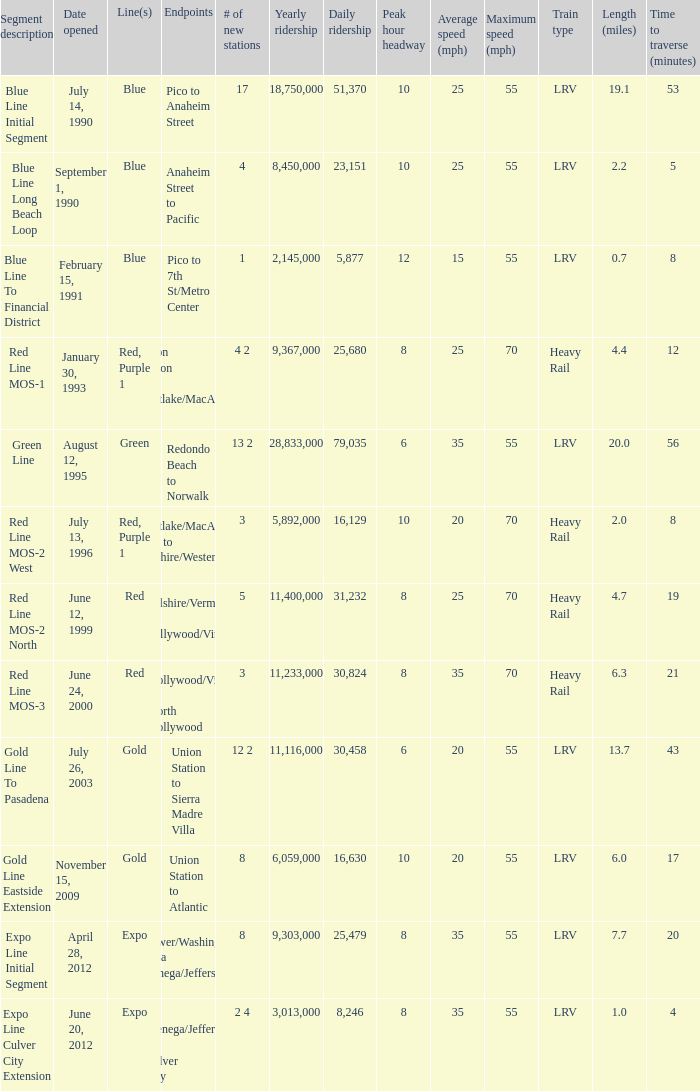How many news stations opened on the date of June 24, 2000? 3.0. 